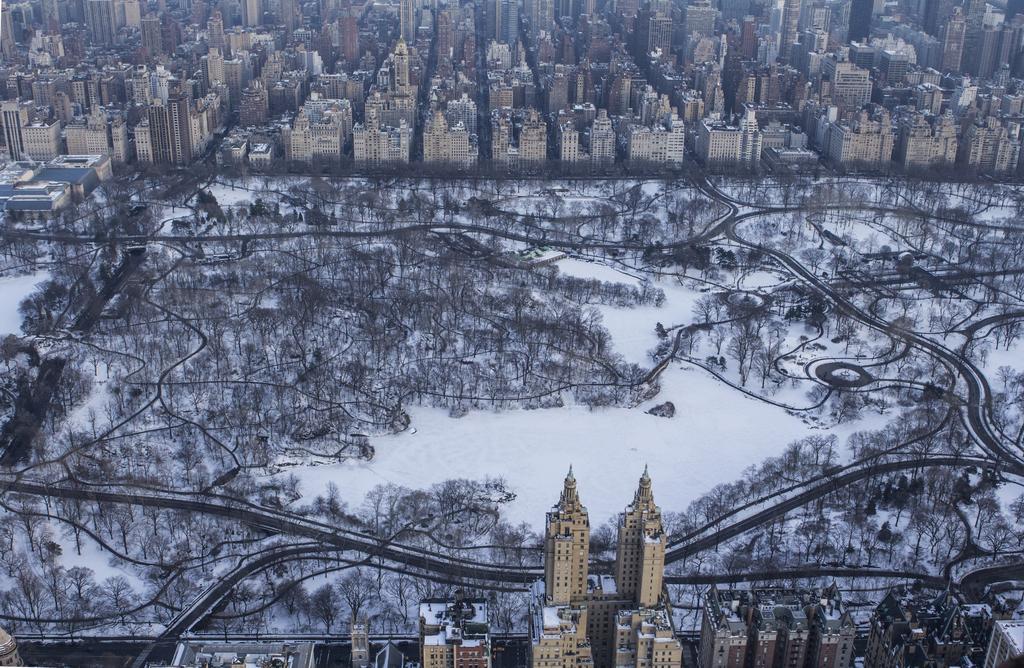Please provide a concise description of this image. In this image we can see snow, trees and roads. At the top of the image there are some buildings. At the bottom of the image there are buildings. 